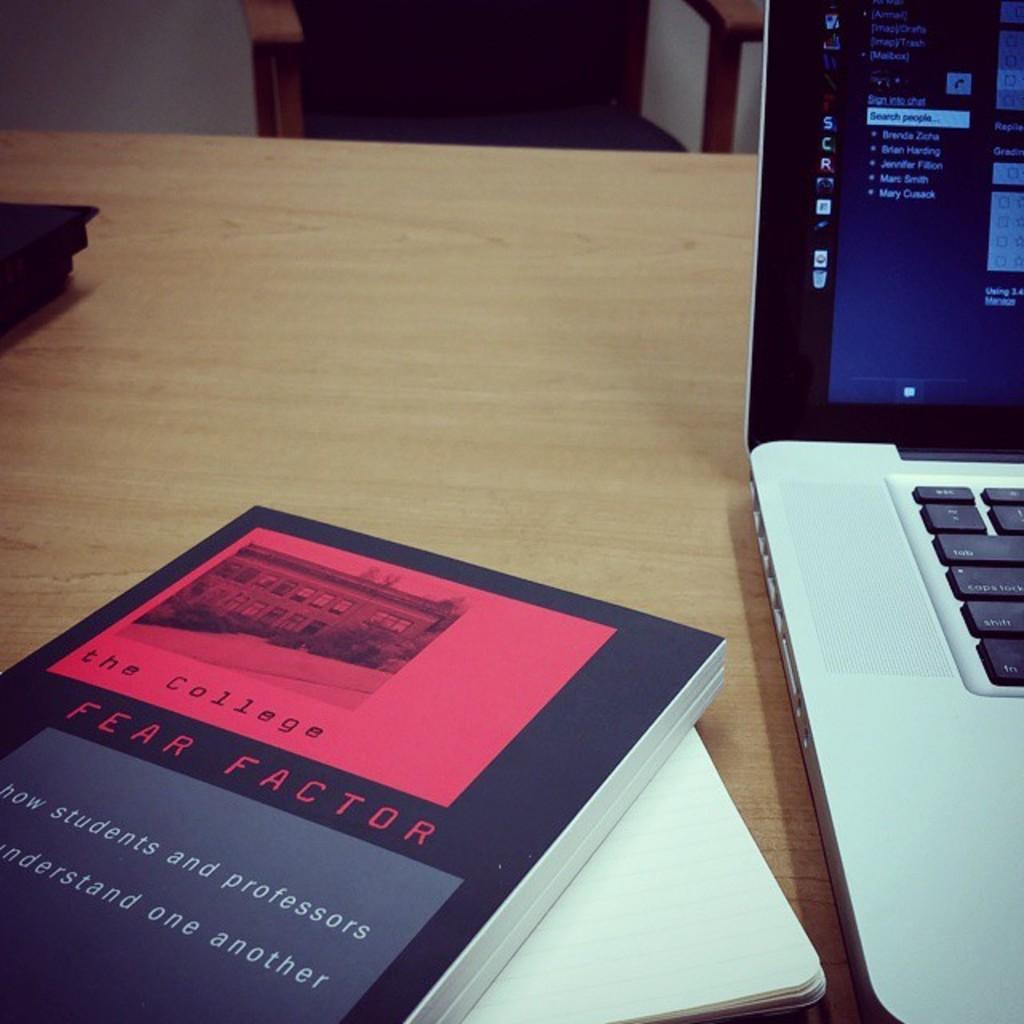<image>
Render a clear and concise summary of the photo. The book "The College Fear Factor" is shown laying next to a laptop. 